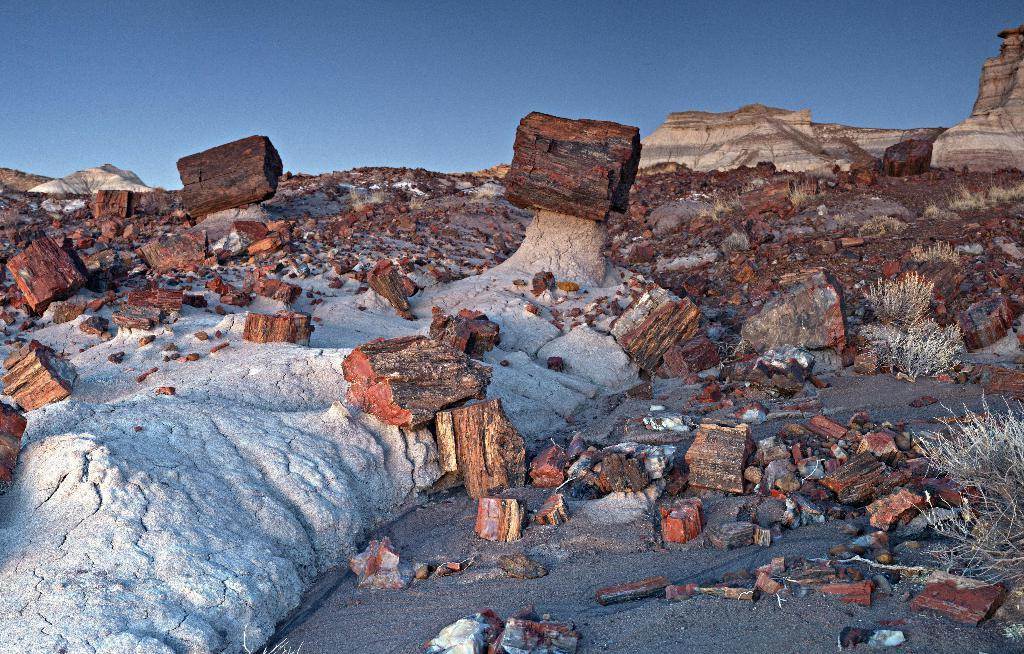What type of natural materials can be seen in the image? There are wooden logs and pieces of wood in the image. What other natural elements are present in the image? There are dried plants in the image. What can be seen in the background of the image? Hills and the sky are visible in the background of the image. What type of peace treaty is being signed in the image? There is no indication of a peace treaty or any signing event in the image. 